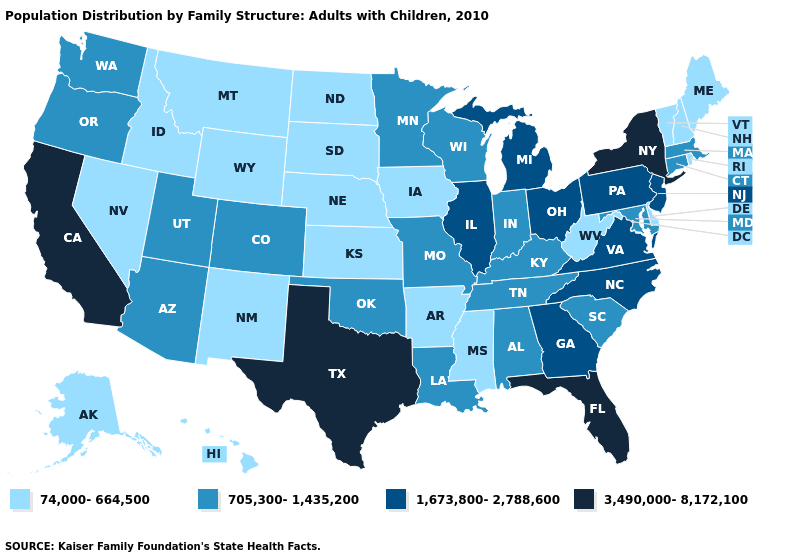What is the highest value in states that border Illinois?
Write a very short answer. 705,300-1,435,200. What is the value of Connecticut?
Keep it brief. 705,300-1,435,200. Name the states that have a value in the range 705,300-1,435,200?
Short answer required. Alabama, Arizona, Colorado, Connecticut, Indiana, Kentucky, Louisiana, Maryland, Massachusetts, Minnesota, Missouri, Oklahoma, Oregon, South Carolina, Tennessee, Utah, Washington, Wisconsin. Name the states that have a value in the range 1,673,800-2,788,600?
Keep it brief. Georgia, Illinois, Michigan, New Jersey, North Carolina, Ohio, Pennsylvania, Virginia. Does Kansas have the same value as Vermont?
Answer briefly. Yes. What is the highest value in states that border Washington?
Write a very short answer. 705,300-1,435,200. What is the value of New York?
Write a very short answer. 3,490,000-8,172,100. What is the highest value in the West ?
Be succinct. 3,490,000-8,172,100. Name the states that have a value in the range 1,673,800-2,788,600?
Answer briefly. Georgia, Illinois, Michigan, New Jersey, North Carolina, Ohio, Pennsylvania, Virginia. Does the first symbol in the legend represent the smallest category?
Give a very brief answer. Yes. Does Nebraska have the lowest value in the USA?
Answer briefly. Yes. What is the value of Louisiana?
Quick response, please. 705,300-1,435,200. Among the states that border Kansas , which have the highest value?
Answer briefly. Colorado, Missouri, Oklahoma. What is the value of Alaska?
Give a very brief answer. 74,000-664,500. Among the states that border Wyoming , which have the highest value?
Keep it brief. Colorado, Utah. 